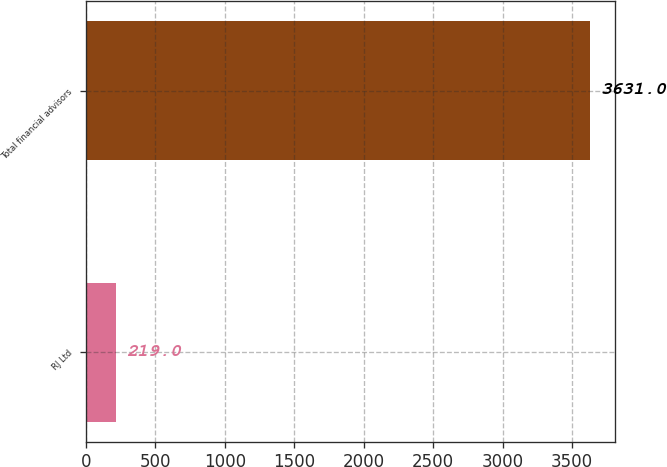<chart> <loc_0><loc_0><loc_500><loc_500><bar_chart><fcel>RJ Ltd<fcel>Total financial advisors<nl><fcel>219<fcel>3631<nl></chart> 